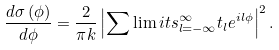Convert formula to latex. <formula><loc_0><loc_0><loc_500><loc_500>\frac { d \sigma \left ( \phi \right ) } { d \phi } = \frac { 2 } { \pi k } \left | \sum \lim i t s _ { l = - \infty } ^ { \infty } t _ { l } e ^ { i l \phi } \right | ^ { 2 } .</formula> 